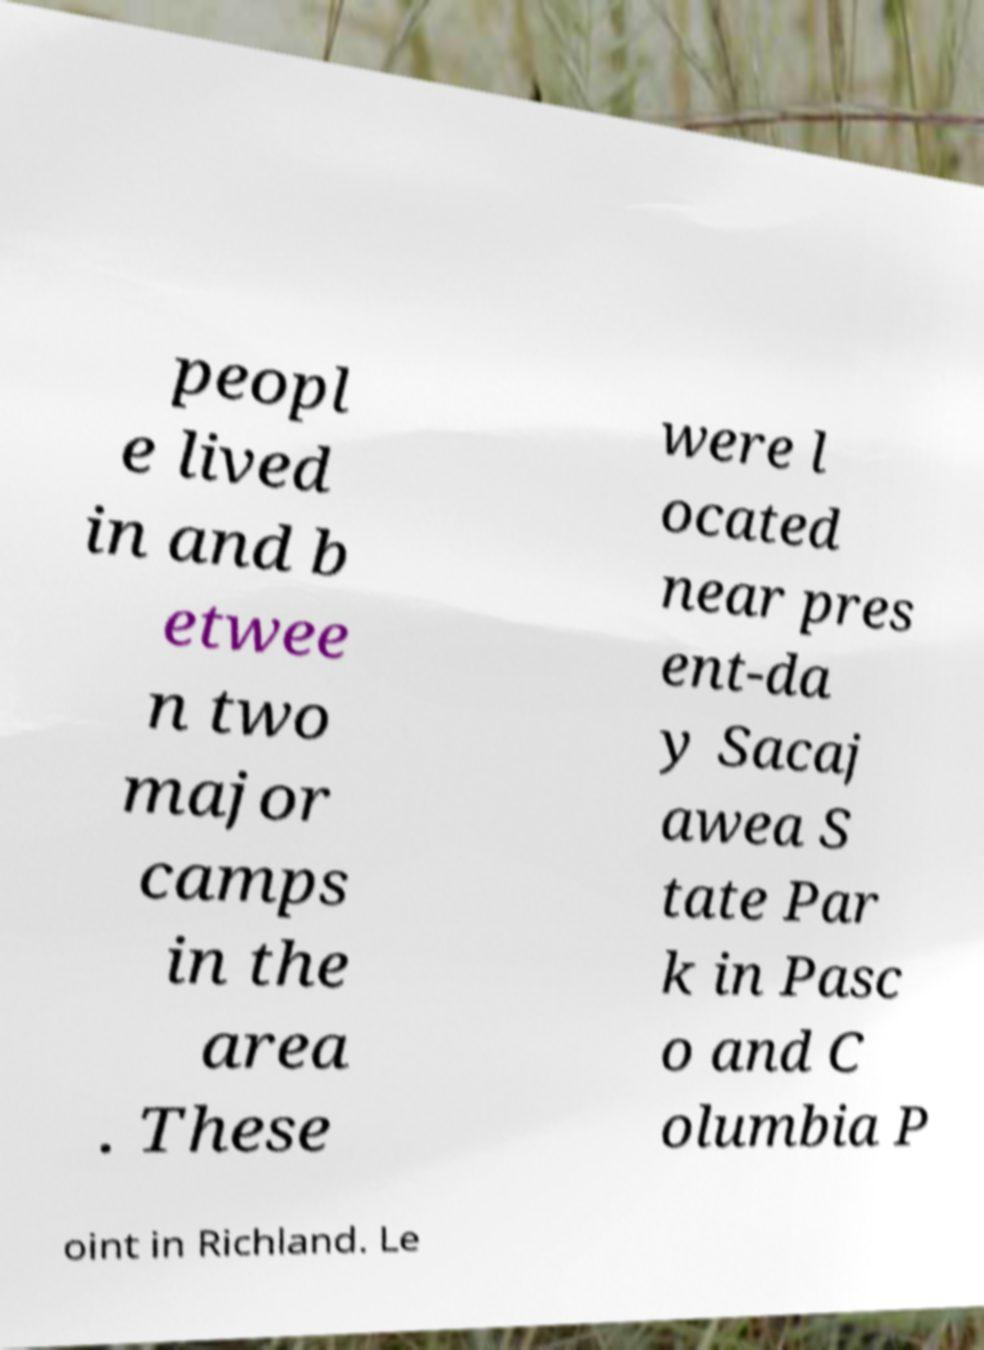Please read and relay the text visible in this image. What does it say? peopl e lived in and b etwee n two major camps in the area . These were l ocated near pres ent-da y Sacaj awea S tate Par k in Pasc o and C olumbia P oint in Richland. Le 